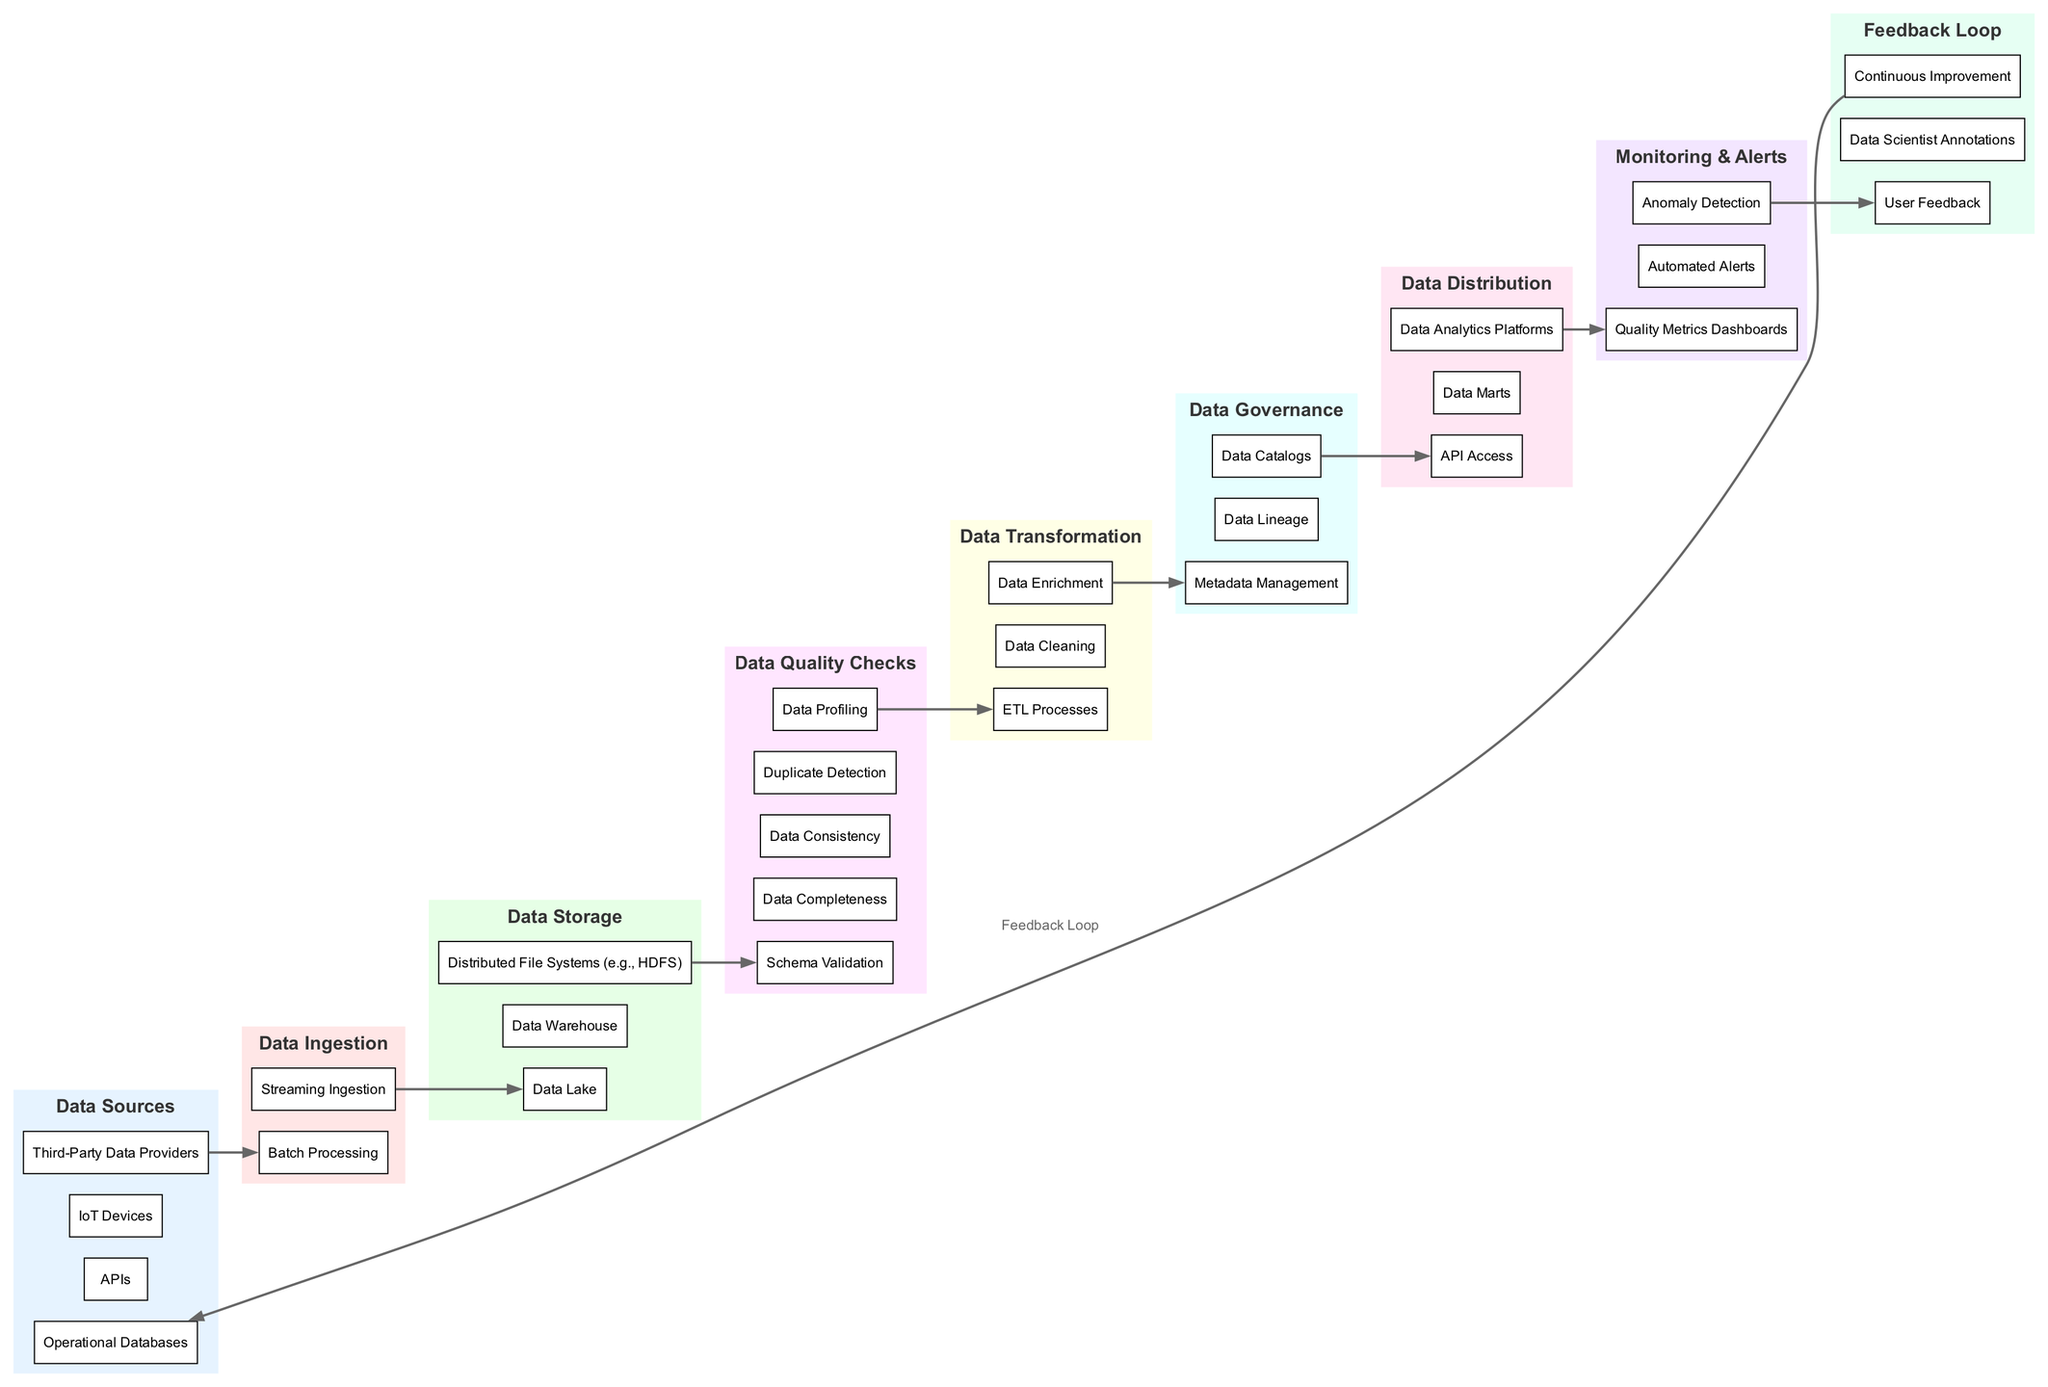What are the elements of the "Data Sources" block? The "Data Sources" block contains four elements: Operational Databases, APIs, IoT Devices, and Third-Party Data Providers.
Answer: Operational Databases, APIs, IoT Devices, Third-Party Data Providers How many elements are in the "Data Quality Checks" block? The "Data Quality Checks" block consists of five elements: Schema Validation, Data Completeness, Data Consistency, Duplicate Detection, and Data Profiling. Therefore, there are a total of five elements.
Answer: 5 Which block follows the "Data Ingestion" block? The "Data Storage" block directly follows the "Data Ingestion" block according to the flow of the diagram.
Answer: Data Storage What is the last element of the "Data Transformation" block? The last element in the "Data Transformation" block is "Data Enrichment". By checking the elements listed under the "Data Transformation" block, we find that "Data Enrichment" is the last listed element.
Answer: Data Enrichment How does data flow from "Data Quality Checks" to "Data Transformation"? Data flows from "Data Quality Checks" to "Data Transformation" through a directed edge that connects the last element of "Data Quality Checks" to the first element of "Data Transformation", indicating that quality checked data enters the transformation stage.
Answer: Directed edge What is the significance of the "Feedback Loop" in the diagram? The "Feedback Loop" connects the end of the data distribution process back to the start, meaning that insights and user feedback are used to improve the initial data sourcing process. This indicates a continuous improvement cycle across the diagram.
Answer: Continuous improvement Which two blocks are connected by the "Monitoring & Alerts" block? The "Monitoring & Alerts" block serves to provide quality assurance across two other blocks: "Data Quality Checks" and "Data Distribution". It monitors the quality after checks and before distribution.
Answer: Data Quality Checks and Data Distribution How many total blocks are represented in the diagram? Upon analysis, the diagram contains nine distinct blocks, represented by their names: Data Sources, Data Ingestion, Data Storage, Data Quality Checks, Data Transformation, Data Governance, Data Distribution, Monitoring & Alerts, and Feedback Loop, leading to a total of nine blocks.
Answer: 9 What is the purpose of the "Data Governance" block? The "Data Governance" block focuses on ensuring data quality through controls such as Metadata Management, Data Lineage, and Data Catalogs. This block supports the overall structure of quality assurance in the data pipeline.
Answer: Data quality controls 